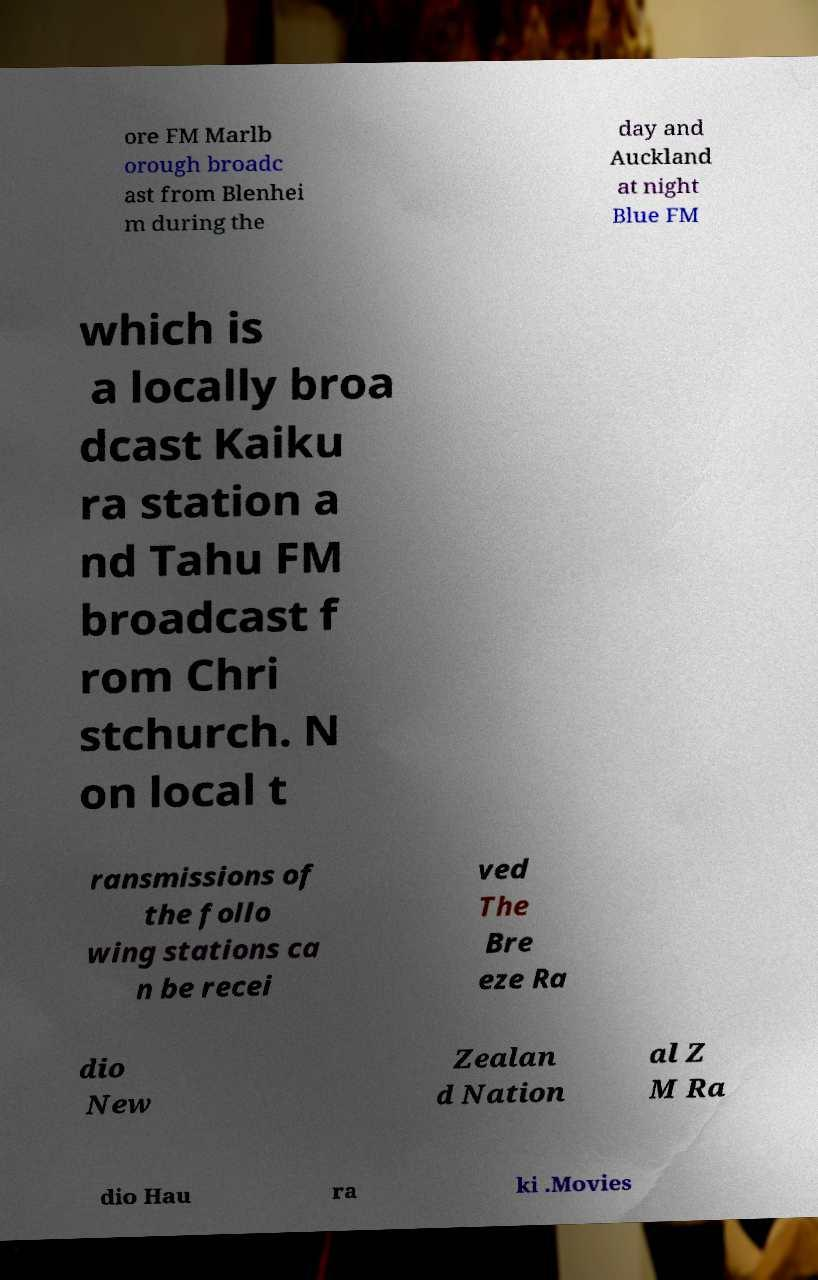Please read and relay the text visible in this image. What does it say? ore FM Marlb orough broadc ast from Blenhei m during the day and Auckland at night Blue FM which is a locally broa dcast Kaiku ra station a nd Tahu FM broadcast f rom Chri stchurch. N on local t ransmissions of the follo wing stations ca n be recei ved The Bre eze Ra dio New Zealan d Nation al Z M Ra dio Hau ra ki .Movies 